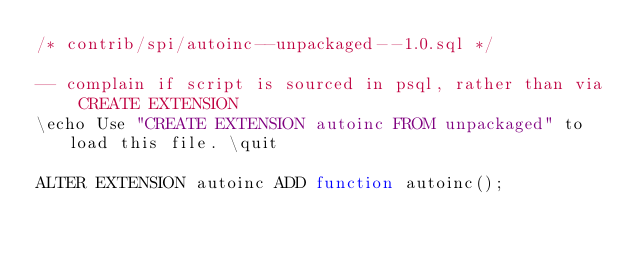<code> <loc_0><loc_0><loc_500><loc_500><_SQL_>/* contrib/spi/autoinc--unpackaged--1.0.sql */

-- complain if script is sourced in psql, rather than via CREATE EXTENSION
\echo Use "CREATE EXTENSION autoinc FROM unpackaged" to load this file. \quit

ALTER EXTENSION autoinc ADD function autoinc();
</code> 